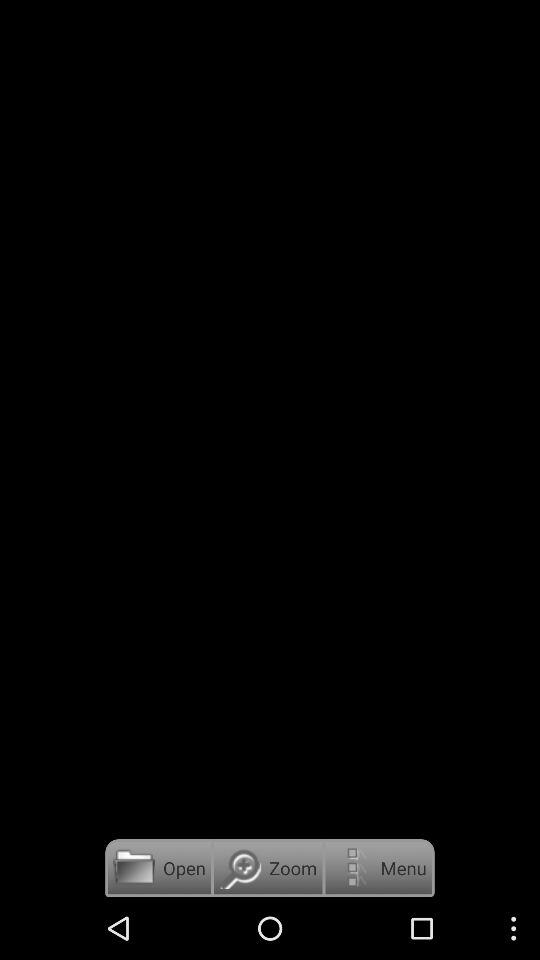What is the application name? The application name is "Kingdom Song Book". 